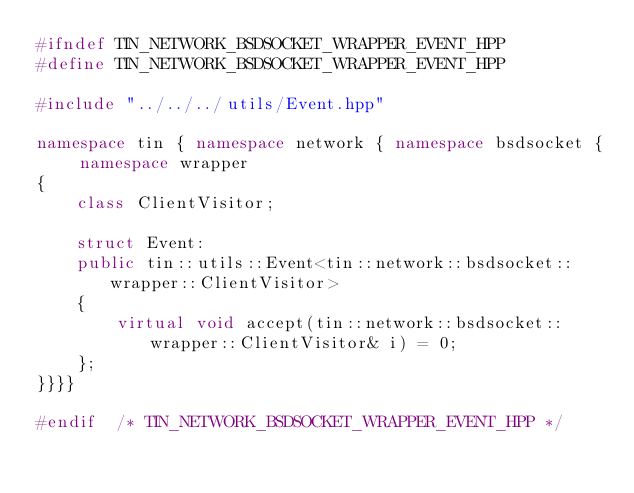<code> <loc_0><loc_0><loc_500><loc_500><_C++_>#ifndef TIN_NETWORK_BSDSOCKET_WRAPPER_EVENT_HPP
#define TIN_NETWORK_BSDSOCKET_WRAPPER_EVENT_HPP

#include "../../../utils/Event.hpp"

namespace tin { namespace network { namespace bsdsocket { namespace wrapper
{
    class ClientVisitor;

    struct Event:
    public tin::utils::Event<tin::network::bsdsocket::wrapper::ClientVisitor>
    {
        virtual void accept(tin::network::bsdsocket::wrapper::ClientVisitor& i) = 0;
    };
}}}}

#endif  /* TIN_NETWORK_BSDSOCKET_WRAPPER_EVENT_HPP */

</code> 